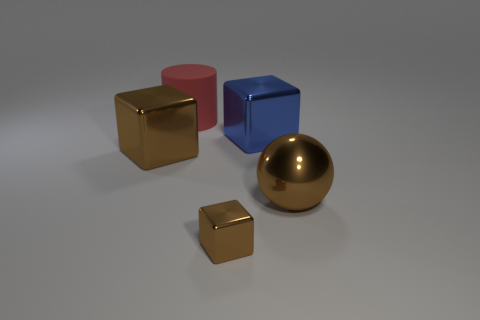Add 2 big blue shiny blocks. How many objects exist? 7 Subtract all cylinders. How many objects are left? 4 Add 1 large matte cylinders. How many large matte cylinders are left? 2 Add 2 brown balls. How many brown balls exist? 3 Subtract 0 green balls. How many objects are left? 5 Subtract all red things. Subtract all big brown balls. How many objects are left? 3 